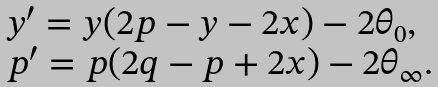<formula> <loc_0><loc_0><loc_500><loc_500>\begin{array} { l } y ^ { \prime } = y ( 2 p - y - 2 x ) - 2 \theta _ { 0 } , \\ p ^ { \prime } = p ( 2 q - p + 2 x ) - 2 \theta _ { \infty } . \end{array}</formula> 